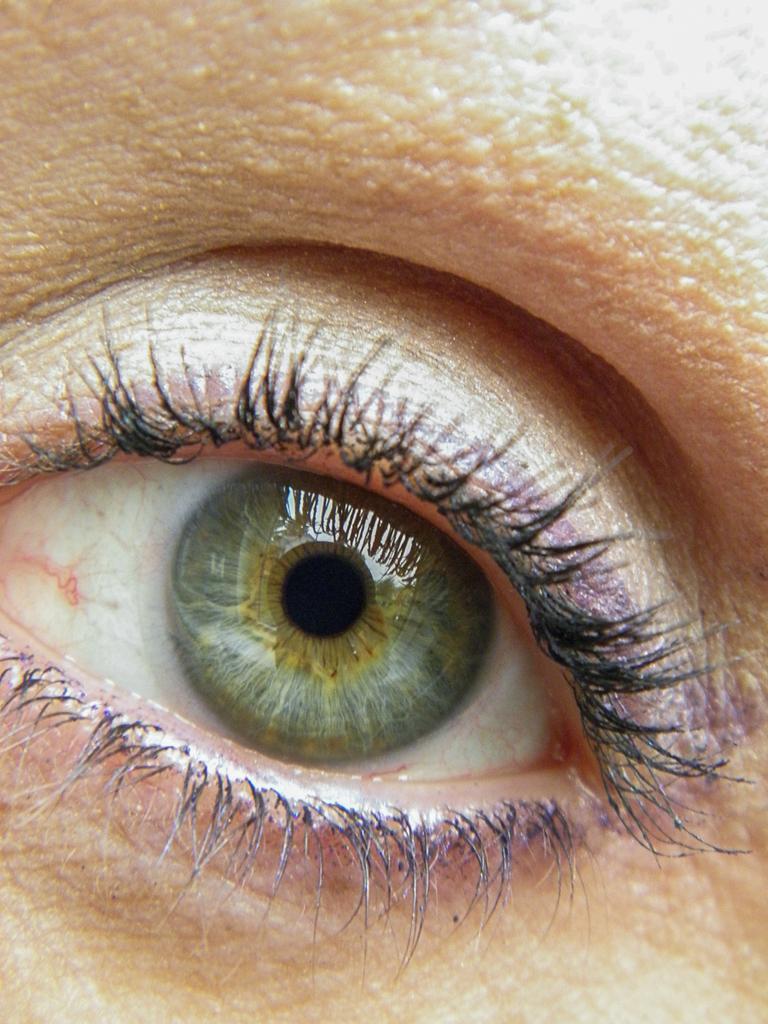Could you give a brief overview of what you see in this image? In the center of the image there is a person's eye. 